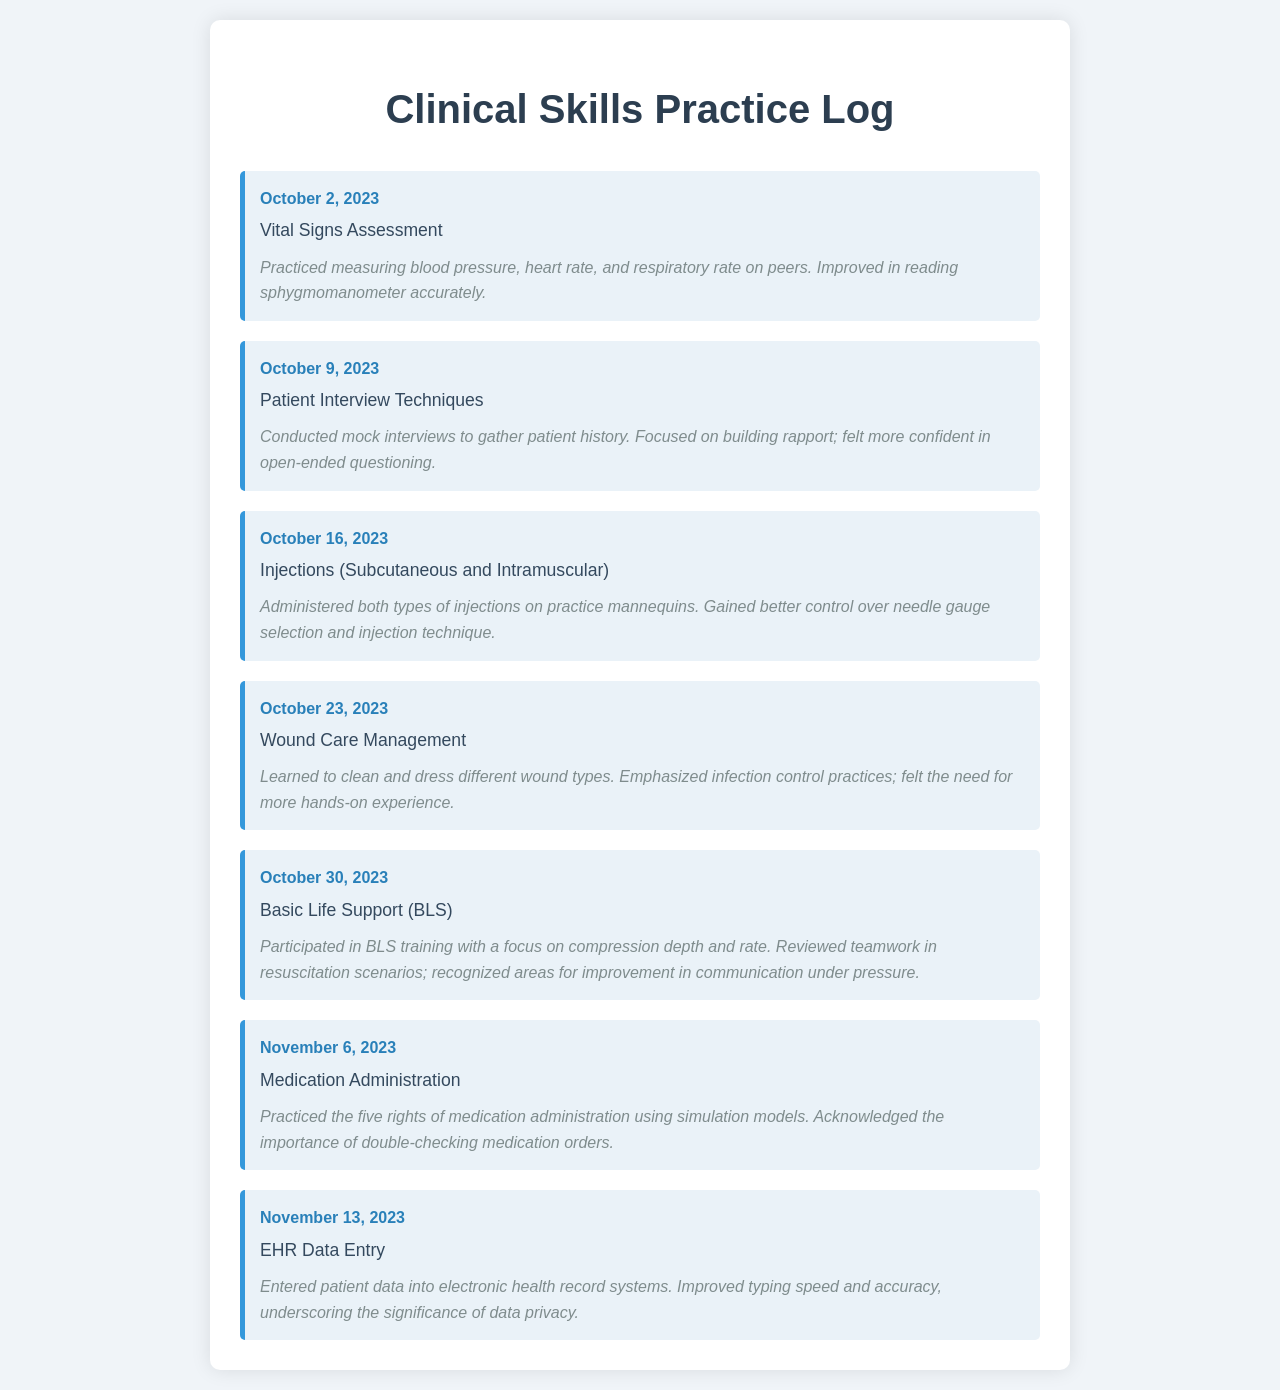What skill was practiced on October 2, 2023? The entry for October 2, 2023, specifies the skill practiced as "Vital Signs Assessment."
Answer: Vital Signs Assessment On which date was Wound Care Management practiced? The schedule lists the skill "Wound Care Management" with the date next to it, which is October 23, 2023.
Answer: October 23, 2023 What improvement was noted during the Basic Life Support training? The notes from the Basic Life Support training highlight the recognition of areas for improvement in communication under pressure.
Answer: Communication under pressure How many skills were practiced before November 6, 2023? By counting the skills listed in the schedule before November 6, 2023, there are six skills in total.
Answer: Six Which skill involved administering injections? The entry that corresponds to administering injections is labeled "Injections (Subcutaneous and Intramuscular)."
Answer: Injections (Subcutaneous and Intramuscular) What is the main focus of the Patient Interview Techniques? The reflection notes indicate a focus on building rapport while conducting mock interviews to gather patient history.
Answer: Building rapport What significant action was emphasized during the Medication Administration practice? The notes discuss the importance of double-checking medication orders during the practice of Medication Administration.
Answer: Double-checking medication orders Which skill practiced on October 30, 2023, involves teamwork? The skill "Basic Life Support (BLS)" practiced on October 30, 2023, is the one associated with teamwork in resuscitation scenarios.
Answer: Basic Life Support (BLS) 